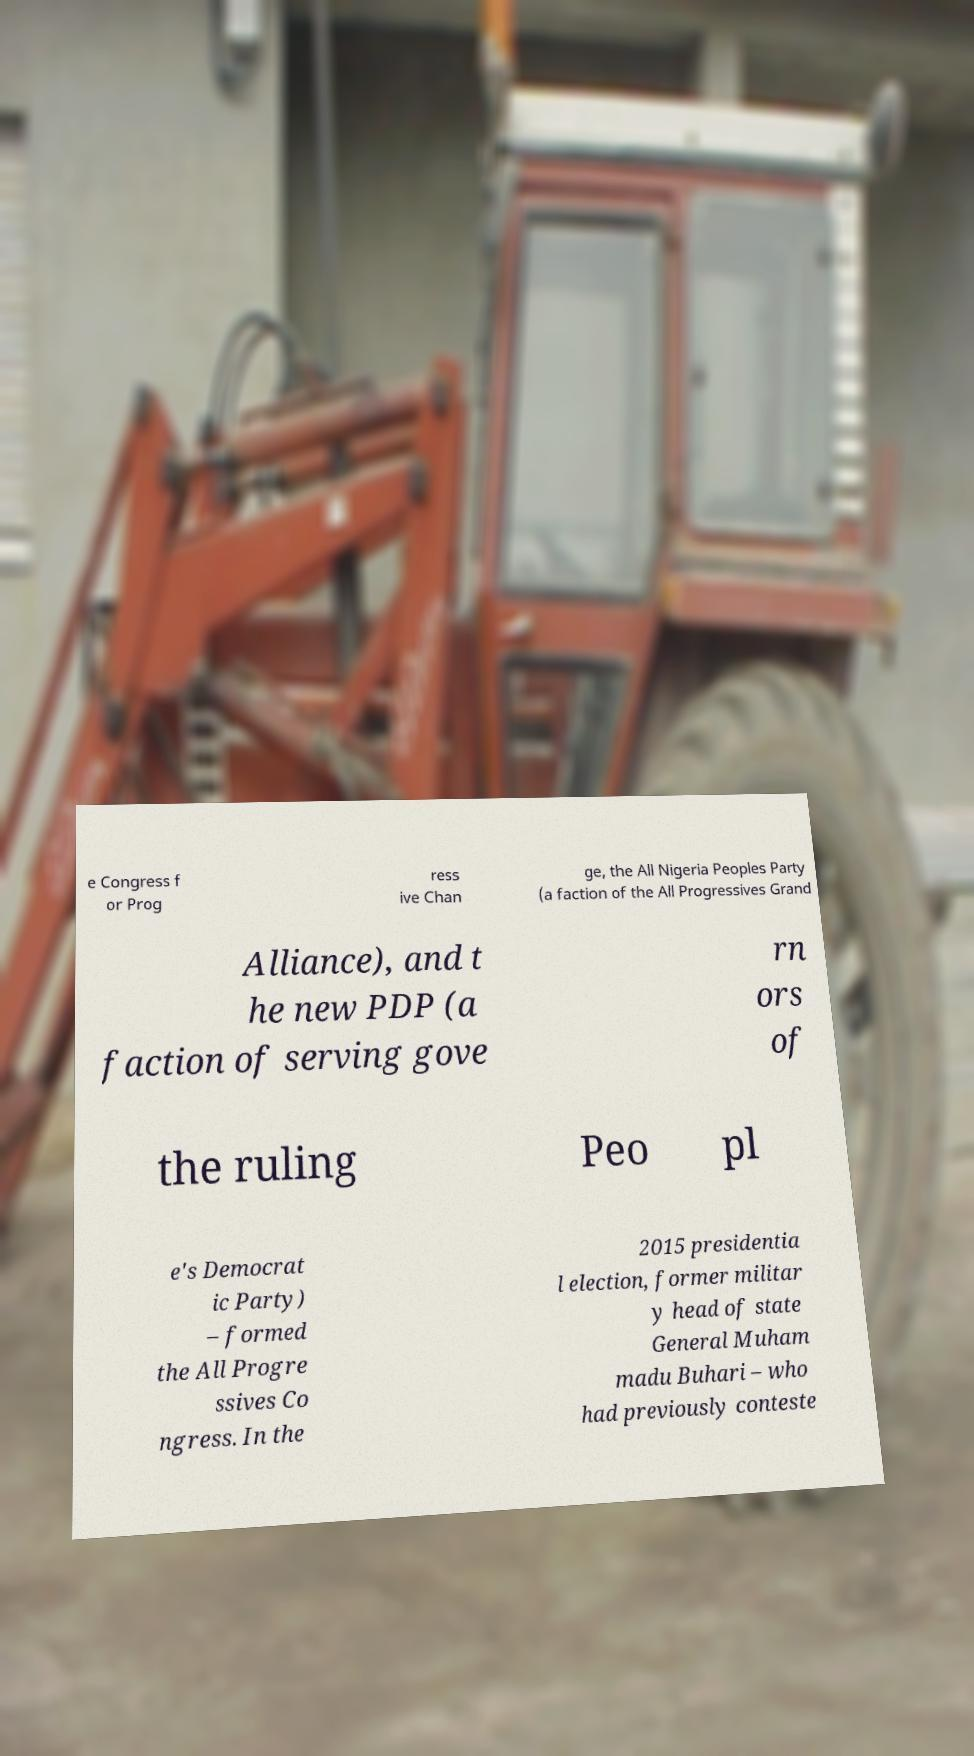Please read and relay the text visible in this image. What does it say? e Congress f or Prog ress ive Chan ge, the All Nigeria Peoples Party (a faction of the All Progressives Grand Alliance), and t he new PDP (a faction of serving gove rn ors of the ruling Peo pl e's Democrat ic Party) – formed the All Progre ssives Co ngress. In the 2015 presidentia l election, former militar y head of state General Muham madu Buhari – who had previously conteste 